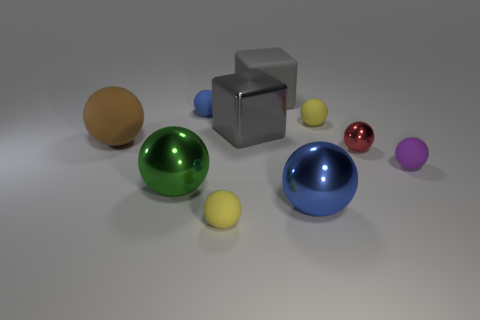Subtract all large metal spheres. How many spheres are left? 6 Subtract all green spheres. How many spheres are left? 7 Subtract all gray spheres. Subtract all brown cylinders. How many spheres are left? 8 Subtract all spheres. How many objects are left? 2 Subtract all blue metallic spheres. Subtract all large metallic cubes. How many objects are left? 8 Add 8 brown spheres. How many brown spheres are left? 9 Add 3 tiny purple rubber spheres. How many tiny purple rubber spheres exist? 4 Subtract 0 brown cubes. How many objects are left? 10 